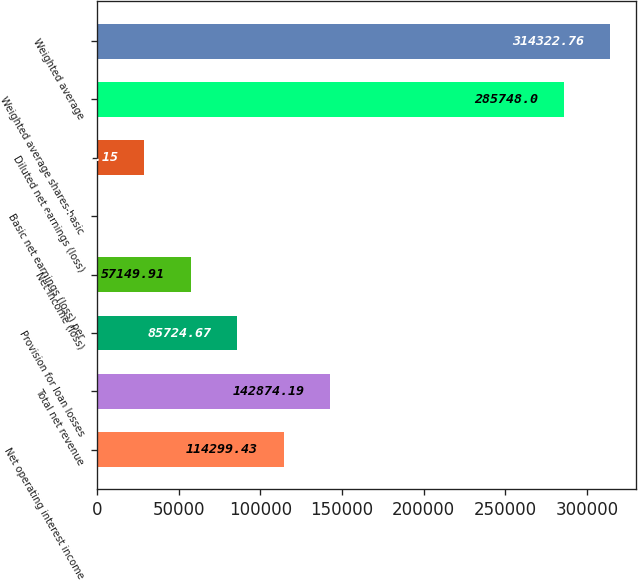Convert chart. <chart><loc_0><loc_0><loc_500><loc_500><bar_chart><fcel>Net operating interest income<fcel>Total net revenue<fcel>Provision for loan losses<fcel>Net income (loss)<fcel>Basic net earnings (loss) per<fcel>Diluted net earnings (loss)<fcel>Weighted average shares-basic<fcel>Weighted average<nl><fcel>114299<fcel>142874<fcel>85724.7<fcel>57149.9<fcel>0.39<fcel>28575.2<fcel>285748<fcel>314323<nl></chart> 